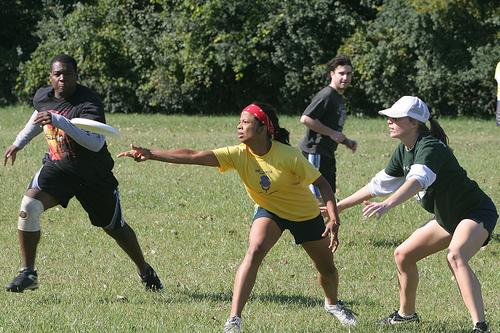Describe the sentiment or emotion the image evokes. The image evokes a sense of excitement, joy, and camaraderie among the players as they enjoy a game of ultimate frisbee in the park. Mention one distinctive feature for each of the four people in the image. One person is wearing a yellow shirt, another has a red headband, the third one has a white hat, and the fourth one is wearing a black shirt. In the image, what is the approximate number of pieces of grass under the body of the person? There are approximately 12 pieces of grass under the person's body. What type of attire can be seen on the woman with a red bandana in her hair? She is wearing a yellow tee shirt. Examine the image carefully and provide the color of the shirt worn by one of the men. One of the men is wearing a black shirt. Identify the color of the frisbee and what it is doing in the image. The frisbee is white and it is flying in midair. Can you find any woman wearing a hat and describe her outfit? Yes, there is a woman wearing a white baseball cap and a green tee shirt over a white sweater. Describe the setting of the image and point out any distinctive features of the environment. The setting is a park with green grass and trees growing on the edge of the field. What are the four people standing in the field doing? The four people are playing ultimate frisbee in the park. How many people are there in the image and what are they engaged in? There are four people in the image who are playing ultimate frisbee in a park. Can you spot the purple umbrella in the image? There is no mention of a purple umbrella in any of the provided captions, so it likely does not exist in the image. The instruction is misleading because it asks the viewer to find a non-existent object. What food items are the people in the park eating? None of the captions reference food or people eating. This interrogative sentence is misleading as it implies that food items are visible in the image, which they are not. There is a tall, white fence in the background of this image. None of the given captions mention a fence, let alone a tall, white one. The declarative sentence is misleading as it falsely states the presence of a nonexistent object in the image. Find the dog playing fetch with the frisbee. While there are mentions of people playing with a frisbee, there is no mention of a dog in any of the captions. This instruction is misleading because it suggests the presence of a dog engaging in an activity, which doesn't appear to be in the image. Look for the child on the swing set. None of the given captions mention a child or a swing set; this implies that there isn't one in the image. The instruction is misleading as it directs the viewer to search for something that is not there. Notice the couple taking a selfie in the corner. Although several captions mention groups of people, there is no mention of a couple taking a selfie. This instruction is misleading because it suggests that there is an additional element in the image that has not been described in the captions. 